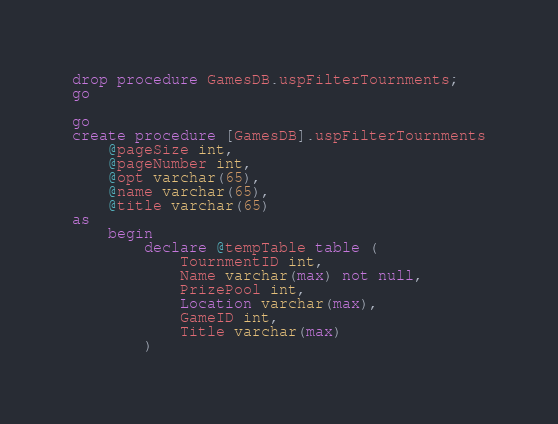Convert code to text. <code><loc_0><loc_0><loc_500><loc_500><_SQL_>drop procedure GamesDB.uspFilterTournments;
go

go
create procedure [GamesDB].uspFilterTournments
	@pageSize int,
	@pageNumber int,
	@opt varchar(65),
	@name varchar(65),
	@title varchar(65)
as
	begin
		declare @tempTable table (
			TournmentID int,
			Name varchar(max) not null,
			PrizePool int,
			Location varchar(max),
			GameID int,
			Title varchar(max)
		)</code> 